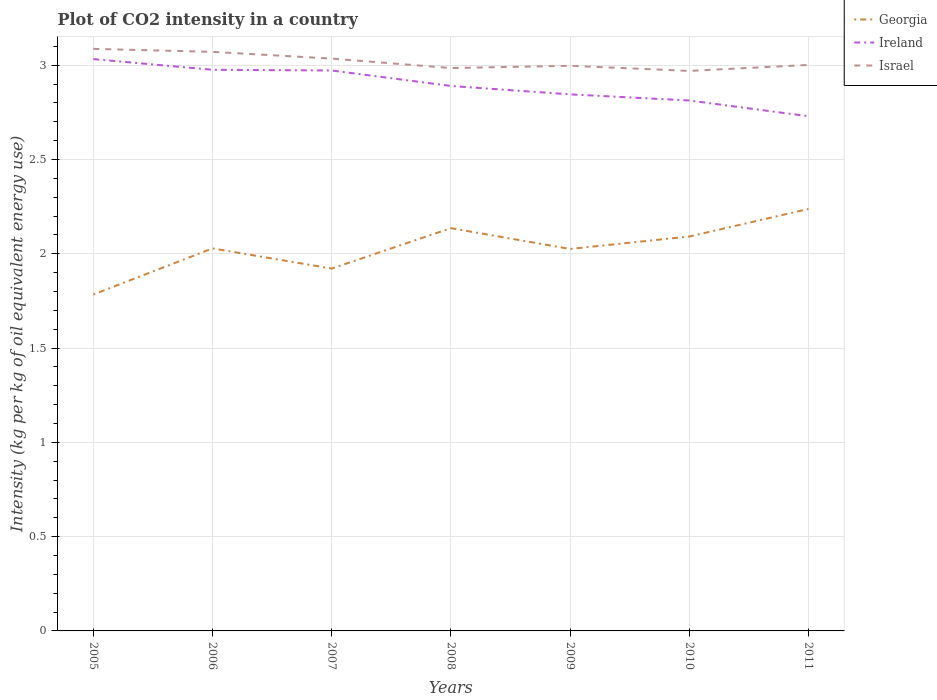How many different coloured lines are there?
Your response must be concise. 3. Does the line corresponding to Georgia intersect with the line corresponding to Ireland?
Your answer should be compact. No. Across all years, what is the maximum CO2 intensity in in Israel?
Keep it short and to the point. 2.97. What is the total CO2 intensity in in Ireland in the graph?
Your response must be concise. 0.24. What is the difference between the highest and the second highest CO2 intensity in in Israel?
Your answer should be compact. 0.12. What is the difference between the highest and the lowest CO2 intensity in in Georgia?
Your answer should be very brief. 3. How many lines are there?
Give a very brief answer. 3. What is the difference between two consecutive major ticks on the Y-axis?
Ensure brevity in your answer.  0.5. Does the graph contain any zero values?
Provide a succinct answer. No. Does the graph contain grids?
Your response must be concise. Yes. How many legend labels are there?
Keep it short and to the point. 3. What is the title of the graph?
Ensure brevity in your answer.  Plot of CO2 intensity in a country. What is the label or title of the Y-axis?
Ensure brevity in your answer.  Intensity (kg per kg of oil equivalent energy use). What is the Intensity (kg per kg of oil equivalent energy use) in Georgia in 2005?
Your answer should be compact. 1.78. What is the Intensity (kg per kg of oil equivalent energy use) in Ireland in 2005?
Your answer should be very brief. 3.03. What is the Intensity (kg per kg of oil equivalent energy use) of Israel in 2005?
Offer a very short reply. 3.09. What is the Intensity (kg per kg of oil equivalent energy use) of Georgia in 2006?
Your answer should be very brief. 2.03. What is the Intensity (kg per kg of oil equivalent energy use) in Ireland in 2006?
Your response must be concise. 2.98. What is the Intensity (kg per kg of oil equivalent energy use) of Israel in 2006?
Keep it short and to the point. 3.07. What is the Intensity (kg per kg of oil equivalent energy use) in Georgia in 2007?
Give a very brief answer. 1.92. What is the Intensity (kg per kg of oil equivalent energy use) in Ireland in 2007?
Give a very brief answer. 2.97. What is the Intensity (kg per kg of oil equivalent energy use) of Israel in 2007?
Your response must be concise. 3.04. What is the Intensity (kg per kg of oil equivalent energy use) of Georgia in 2008?
Your response must be concise. 2.14. What is the Intensity (kg per kg of oil equivalent energy use) of Ireland in 2008?
Offer a terse response. 2.89. What is the Intensity (kg per kg of oil equivalent energy use) in Israel in 2008?
Ensure brevity in your answer.  2.99. What is the Intensity (kg per kg of oil equivalent energy use) of Georgia in 2009?
Offer a terse response. 2.03. What is the Intensity (kg per kg of oil equivalent energy use) in Ireland in 2009?
Make the answer very short. 2.85. What is the Intensity (kg per kg of oil equivalent energy use) in Israel in 2009?
Ensure brevity in your answer.  3. What is the Intensity (kg per kg of oil equivalent energy use) of Georgia in 2010?
Make the answer very short. 2.09. What is the Intensity (kg per kg of oil equivalent energy use) in Ireland in 2010?
Provide a succinct answer. 2.81. What is the Intensity (kg per kg of oil equivalent energy use) of Israel in 2010?
Ensure brevity in your answer.  2.97. What is the Intensity (kg per kg of oil equivalent energy use) of Georgia in 2011?
Keep it short and to the point. 2.24. What is the Intensity (kg per kg of oil equivalent energy use) of Ireland in 2011?
Provide a succinct answer. 2.73. What is the Intensity (kg per kg of oil equivalent energy use) of Israel in 2011?
Give a very brief answer. 3. Across all years, what is the maximum Intensity (kg per kg of oil equivalent energy use) of Georgia?
Offer a terse response. 2.24. Across all years, what is the maximum Intensity (kg per kg of oil equivalent energy use) in Ireland?
Your answer should be very brief. 3.03. Across all years, what is the maximum Intensity (kg per kg of oil equivalent energy use) of Israel?
Your answer should be very brief. 3.09. Across all years, what is the minimum Intensity (kg per kg of oil equivalent energy use) in Georgia?
Provide a succinct answer. 1.78. Across all years, what is the minimum Intensity (kg per kg of oil equivalent energy use) in Ireland?
Give a very brief answer. 2.73. Across all years, what is the minimum Intensity (kg per kg of oil equivalent energy use) of Israel?
Provide a succinct answer. 2.97. What is the total Intensity (kg per kg of oil equivalent energy use) of Georgia in the graph?
Offer a terse response. 14.23. What is the total Intensity (kg per kg of oil equivalent energy use) in Ireland in the graph?
Provide a short and direct response. 20.26. What is the total Intensity (kg per kg of oil equivalent energy use) of Israel in the graph?
Give a very brief answer. 21.15. What is the difference between the Intensity (kg per kg of oil equivalent energy use) in Georgia in 2005 and that in 2006?
Ensure brevity in your answer.  -0.24. What is the difference between the Intensity (kg per kg of oil equivalent energy use) of Ireland in 2005 and that in 2006?
Your answer should be compact. 0.06. What is the difference between the Intensity (kg per kg of oil equivalent energy use) of Israel in 2005 and that in 2006?
Keep it short and to the point. 0.02. What is the difference between the Intensity (kg per kg of oil equivalent energy use) of Georgia in 2005 and that in 2007?
Offer a terse response. -0.14. What is the difference between the Intensity (kg per kg of oil equivalent energy use) of Ireland in 2005 and that in 2007?
Your response must be concise. 0.06. What is the difference between the Intensity (kg per kg of oil equivalent energy use) in Israel in 2005 and that in 2007?
Offer a terse response. 0.05. What is the difference between the Intensity (kg per kg of oil equivalent energy use) in Georgia in 2005 and that in 2008?
Keep it short and to the point. -0.35. What is the difference between the Intensity (kg per kg of oil equivalent energy use) in Ireland in 2005 and that in 2008?
Your answer should be compact. 0.14. What is the difference between the Intensity (kg per kg of oil equivalent energy use) of Israel in 2005 and that in 2008?
Provide a short and direct response. 0.1. What is the difference between the Intensity (kg per kg of oil equivalent energy use) in Georgia in 2005 and that in 2009?
Keep it short and to the point. -0.24. What is the difference between the Intensity (kg per kg of oil equivalent energy use) in Ireland in 2005 and that in 2009?
Your answer should be compact. 0.19. What is the difference between the Intensity (kg per kg of oil equivalent energy use) of Israel in 2005 and that in 2009?
Make the answer very short. 0.09. What is the difference between the Intensity (kg per kg of oil equivalent energy use) in Georgia in 2005 and that in 2010?
Give a very brief answer. -0.31. What is the difference between the Intensity (kg per kg of oil equivalent energy use) of Ireland in 2005 and that in 2010?
Your response must be concise. 0.22. What is the difference between the Intensity (kg per kg of oil equivalent energy use) of Israel in 2005 and that in 2010?
Your answer should be compact. 0.12. What is the difference between the Intensity (kg per kg of oil equivalent energy use) of Georgia in 2005 and that in 2011?
Provide a short and direct response. -0.45. What is the difference between the Intensity (kg per kg of oil equivalent energy use) of Ireland in 2005 and that in 2011?
Your answer should be very brief. 0.3. What is the difference between the Intensity (kg per kg of oil equivalent energy use) in Israel in 2005 and that in 2011?
Provide a succinct answer. 0.09. What is the difference between the Intensity (kg per kg of oil equivalent energy use) in Georgia in 2006 and that in 2007?
Ensure brevity in your answer.  0.11. What is the difference between the Intensity (kg per kg of oil equivalent energy use) in Ireland in 2006 and that in 2007?
Give a very brief answer. 0. What is the difference between the Intensity (kg per kg of oil equivalent energy use) of Israel in 2006 and that in 2007?
Provide a short and direct response. 0.04. What is the difference between the Intensity (kg per kg of oil equivalent energy use) of Georgia in 2006 and that in 2008?
Keep it short and to the point. -0.11. What is the difference between the Intensity (kg per kg of oil equivalent energy use) in Ireland in 2006 and that in 2008?
Offer a terse response. 0.09. What is the difference between the Intensity (kg per kg of oil equivalent energy use) of Israel in 2006 and that in 2008?
Offer a terse response. 0.09. What is the difference between the Intensity (kg per kg of oil equivalent energy use) in Georgia in 2006 and that in 2009?
Your response must be concise. 0. What is the difference between the Intensity (kg per kg of oil equivalent energy use) of Ireland in 2006 and that in 2009?
Ensure brevity in your answer.  0.13. What is the difference between the Intensity (kg per kg of oil equivalent energy use) of Israel in 2006 and that in 2009?
Provide a succinct answer. 0.07. What is the difference between the Intensity (kg per kg of oil equivalent energy use) in Georgia in 2006 and that in 2010?
Give a very brief answer. -0.06. What is the difference between the Intensity (kg per kg of oil equivalent energy use) of Ireland in 2006 and that in 2010?
Give a very brief answer. 0.16. What is the difference between the Intensity (kg per kg of oil equivalent energy use) in Israel in 2006 and that in 2010?
Give a very brief answer. 0.1. What is the difference between the Intensity (kg per kg of oil equivalent energy use) in Georgia in 2006 and that in 2011?
Give a very brief answer. -0.21. What is the difference between the Intensity (kg per kg of oil equivalent energy use) of Ireland in 2006 and that in 2011?
Offer a terse response. 0.25. What is the difference between the Intensity (kg per kg of oil equivalent energy use) in Israel in 2006 and that in 2011?
Keep it short and to the point. 0.07. What is the difference between the Intensity (kg per kg of oil equivalent energy use) in Georgia in 2007 and that in 2008?
Provide a succinct answer. -0.21. What is the difference between the Intensity (kg per kg of oil equivalent energy use) in Ireland in 2007 and that in 2008?
Offer a terse response. 0.08. What is the difference between the Intensity (kg per kg of oil equivalent energy use) in Israel in 2007 and that in 2008?
Give a very brief answer. 0.05. What is the difference between the Intensity (kg per kg of oil equivalent energy use) of Georgia in 2007 and that in 2009?
Your answer should be compact. -0.1. What is the difference between the Intensity (kg per kg of oil equivalent energy use) in Ireland in 2007 and that in 2009?
Provide a succinct answer. 0.13. What is the difference between the Intensity (kg per kg of oil equivalent energy use) of Israel in 2007 and that in 2009?
Give a very brief answer. 0.04. What is the difference between the Intensity (kg per kg of oil equivalent energy use) in Georgia in 2007 and that in 2010?
Your answer should be compact. -0.17. What is the difference between the Intensity (kg per kg of oil equivalent energy use) in Ireland in 2007 and that in 2010?
Give a very brief answer. 0.16. What is the difference between the Intensity (kg per kg of oil equivalent energy use) of Israel in 2007 and that in 2010?
Give a very brief answer. 0.07. What is the difference between the Intensity (kg per kg of oil equivalent energy use) in Georgia in 2007 and that in 2011?
Keep it short and to the point. -0.32. What is the difference between the Intensity (kg per kg of oil equivalent energy use) in Ireland in 2007 and that in 2011?
Make the answer very short. 0.24. What is the difference between the Intensity (kg per kg of oil equivalent energy use) in Israel in 2007 and that in 2011?
Make the answer very short. 0.03. What is the difference between the Intensity (kg per kg of oil equivalent energy use) in Georgia in 2008 and that in 2009?
Provide a succinct answer. 0.11. What is the difference between the Intensity (kg per kg of oil equivalent energy use) in Ireland in 2008 and that in 2009?
Your response must be concise. 0.04. What is the difference between the Intensity (kg per kg of oil equivalent energy use) of Israel in 2008 and that in 2009?
Ensure brevity in your answer.  -0.01. What is the difference between the Intensity (kg per kg of oil equivalent energy use) of Georgia in 2008 and that in 2010?
Offer a terse response. 0.04. What is the difference between the Intensity (kg per kg of oil equivalent energy use) of Ireland in 2008 and that in 2010?
Provide a short and direct response. 0.08. What is the difference between the Intensity (kg per kg of oil equivalent energy use) of Israel in 2008 and that in 2010?
Make the answer very short. 0.02. What is the difference between the Intensity (kg per kg of oil equivalent energy use) in Georgia in 2008 and that in 2011?
Provide a short and direct response. -0.1. What is the difference between the Intensity (kg per kg of oil equivalent energy use) in Ireland in 2008 and that in 2011?
Provide a short and direct response. 0.16. What is the difference between the Intensity (kg per kg of oil equivalent energy use) in Israel in 2008 and that in 2011?
Your answer should be very brief. -0.02. What is the difference between the Intensity (kg per kg of oil equivalent energy use) of Georgia in 2009 and that in 2010?
Your answer should be compact. -0.07. What is the difference between the Intensity (kg per kg of oil equivalent energy use) in Ireland in 2009 and that in 2010?
Give a very brief answer. 0.03. What is the difference between the Intensity (kg per kg of oil equivalent energy use) of Israel in 2009 and that in 2010?
Offer a terse response. 0.03. What is the difference between the Intensity (kg per kg of oil equivalent energy use) of Georgia in 2009 and that in 2011?
Make the answer very short. -0.21. What is the difference between the Intensity (kg per kg of oil equivalent energy use) of Ireland in 2009 and that in 2011?
Give a very brief answer. 0.12. What is the difference between the Intensity (kg per kg of oil equivalent energy use) of Israel in 2009 and that in 2011?
Your response must be concise. -0. What is the difference between the Intensity (kg per kg of oil equivalent energy use) of Georgia in 2010 and that in 2011?
Provide a short and direct response. -0.15. What is the difference between the Intensity (kg per kg of oil equivalent energy use) in Ireland in 2010 and that in 2011?
Offer a terse response. 0.08. What is the difference between the Intensity (kg per kg of oil equivalent energy use) in Israel in 2010 and that in 2011?
Offer a very short reply. -0.03. What is the difference between the Intensity (kg per kg of oil equivalent energy use) of Georgia in 2005 and the Intensity (kg per kg of oil equivalent energy use) of Ireland in 2006?
Offer a very short reply. -1.19. What is the difference between the Intensity (kg per kg of oil equivalent energy use) in Georgia in 2005 and the Intensity (kg per kg of oil equivalent energy use) in Israel in 2006?
Give a very brief answer. -1.29. What is the difference between the Intensity (kg per kg of oil equivalent energy use) in Ireland in 2005 and the Intensity (kg per kg of oil equivalent energy use) in Israel in 2006?
Give a very brief answer. -0.04. What is the difference between the Intensity (kg per kg of oil equivalent energy use) of Georgia in 2005 and the Intensity (kg per kg of oil equivalent energy use) of Ireland in 2007?
Ensure brevity in your answer.  -1.19. What is the difference between the Intensity (kg per kg of oil equivalent energy use) in Georgia in 2005 and the Intensity (kg per kg of oil equivalent energy use) in Israel in 2007?
Offer a very short reply. -1.25. What is the difference between the Intensity (kg per kg of oil equivalent energy use) of Ireland in 2005 and the Intensity (kg per kg of oil equivalent energy use) of Israel in 2007?
Your answer should be very brief. -0. What is the difference between the Intensity (kg per kg of oil equivalent energy use) of Georgia in 2005 and the Intensity (kg per kg of oil equivalent energy use) of Ireland in 2008?
Your answer should be very brief. -1.11. What is the difference between the Intensity (kg per kg of oil equivalent energy use) in Georgia in 2005 and the Intensity (kg per kg of oil equivalent energy use) in Israel in 2008?
Offer a very short reply. -1.2. What is the difference between the Intensity (kg per kg of oil equivalent energy use) of Ireland in 2005 and the Intensity (kg per kg of oil equivalent energy use) of Israel in 2008?
Your response must be concise. 0.05. What is the difference between the Intensity (kg per kg of oil equivalent energy use) of Georgia in 2005 and the Intensity (kg per kg of oil equivalent energy use) of Ireland in 2009?
Make the answer very short. -1.06. What is the difference between the Intensity (kg per kg of oil equivalent energy use) of Georgia in 2005 and the Intensity (kg per kg of oil equivalent energy use) of Israel in 2009?
Make the answer very short. -1.21. What is the difference between the Intensity (kg per kg of oil equivalent energy use) in Ireland in 2005 and the Intensity (kg per kg of oil equivalent energy use) in Israel in 2009?
Your response must be concise. 0.04. What is the difference between the Intensity (kg per kg of oil equivalent energy use) in Georgia in 2005 and the Intensity (kg per kg of oil equivalent energy use) in Ireland in 2010?
Offer a terse response. -1.03. What is the difference between the Intensity (kg per kg of oil equivalent energy use) in Georgia in 2005 and the Intensity (kg per kg of oil equivalent energy use) in Israel in 2010?
Your answer should be compact. -1.19. What is the difference between the Intensity (kg per kg of oil equivalent energy use) of Ireland in 2005 and the Intensity (kg per kg of oil equivalent energy use) of Israel in 2010?
Your answer should be very brief. 0.06. What is the difference between the Intensity (kg per kg of oil equivalent energy use) in Georgia in 2005 and the Intensity (kg per kg of oil equivalent energy use) in Ireland in 2011?
Provide a succinct answer. -0.95. What is the difference between the Intensity (kg per kg of oil equivalent energy use) in Georgia in 2005 and the Intensity (kg per kg of oil equivalent energy use) in Israel in 2011?
Provide a short and direct response. -1.22. What is the difference between the Intensity (kg per kg of oil equivalent energy use) of Ireland in 2005 and the Intensity (kg per kg of oil equivalent energy use) of Israel in 2011?
Ensure brevity in your answer.  0.03. What is the difference between the Intensity (kg per kg of oil equivalent energy use) of Georgia in 2006 and the Intensity (kg per kg of oil equivalent energy use) of Ireland in 2007?
Ensure brevity in your answer.  -0.94. What is the difference between the Intensity (kg per kg of oil equivalent energy use) of Georgia in 2006 and the Intensity (kg per kg of oil equivalent energy use) of Israel in 2007?
Give a very brief answer. -1.01. What is the difference between the Intensity (kg per kg of oil equivalent energy use) in Ireland in 2006 and the Intensity (kg per kg of oil equivalent energy use) in Israel in 2007?
Offer a very short reply. -0.06. What is the difference between the Intensity (kg per kg of oil equivalent energy use) in Georgia in 2006 and the Intensity (kg per kg of oil equivalent energy use) in Ireland in 2008?
Make the answer very short. -0.86. What is the difference between the Intensity (kg per kg of oil equivalent energy use) in Georgia in 2006 and the Intensity (kg per kg of oil equivalent energy use) in Israel in 2008?
Provide a short and direct response. -0.96. What is the difference between the Intensity (kg per kg of oil equivalent energy use) of Ireland in 2006 and the Intensity (kg per kg of oil equivalent energy use) of Israel in 2008?
Keep it short and to the point. -0.01. What is the difference between the Intensity (kg per kg of oil equivalent energy use) in Georgia in 2006 and the Intensity (kg per kg of oil equivalent energy use) in Ireland in 2009?
Your response must be concise. -0.82. What is the difference between the Intensity (kg per kg of oil equivalent energy use) in Georgia in 2006 and the Intensity (kg per kg of oil equivalent energy use) in Israel in 2009?
Your answer should be compact. -0.97. What is the difference between the Intensity (kg per kg of oil equivalent energy use) of Ireland in 2006 and the Intensity (kg per kg of oil equivalent energy use) of Israel in 2009?
Provide a short and direct response. -0.02. What is the difference between the Intensity (kg per kg of oil equivalent energy use) in Georgia in 2006 and the Intensity (kg per kg of oil equivalent energy use) in Ireland in 2010?
Your response must be concise. -0.78. What is the difference between the Intensity (kg per kg of oil equivalent energy use) in Georgia in 2006 and the Intensity (kg per kg of oil equivalent energy use) in Israel in 2010?
Your answer should be compact. -0.94. What is the difference between the Intensity (kg per kg of oil equivalent energy use) of Ireland in 2006 and the Intensity (kg per kg of oil equivalent energy use) of Israel in 2010?
Provide a succinct answer. 0.01. What is the difference between the Intensity (kg per kg of oil equivalent energy use) in Georgia in 2006 and the Intensity (kg per kg of oil equivalent energy use) in Ireland in 2011?
Ensure brevity in your answer.  -0.7. What is the difference between the Intensity (kg per kg of oil equivalent energy use) of Georgia in 2006 and the Intensity (kg per kg of oil equivalent energy use) of Israel in 2011?
Your answer should be compact. -0.97. What is the difference between the Intensity (kg per kg of oil equivalent energy use) in Ireland in 2006 and the Intensity (kg per kg of oil equivalent energy use) in Israel in 2011?
Your response must be concise. -0.03. What is the difference between the Intensity (kg per kg of oil equivalent energy use) of Georgia in 2007 and the Intensity (kg per kg of oil equivalent energy use) of Ireland in 2008?
Your answer should be very brief. -0.97. What is the difference between the Intensity (kg per kg of oil equivalent energy use) in Georgia in 2007 and the Intensity (kg per kg of oil equivalent energy use) in Israel in 2008?
Provide a succinct answer. -1.06. What is the difference between the Intensity (kg per kg of oil equivalent energy use) in Ireland in 2007 and the Intensity (kg per kg of oil equivalent energy use) in Israel in 2008?
Ensure brevity in your answer.  -0.01. What is the difference between the Intensity (kg per kg of oil equivalent energy use) in Georgia in 2007 and the Intensity (kg per kg of oil equivalent energy use) in Ireland in 2009?
Ensure brevity in your answer.  -0.92. What is the difference between the Intensity (kg per kg of oil equivalent energy use) in Georgia in 2007 and the Intensity (kg per kg of oil equivalent energy use) in Israel in 2009?
Provide a succinct answer. -1.08. What is the difference between the Intensity (kg per kg of oil equivalent energy use) in Ireland in 2007 and the Intensity (kg per kg of oil equivalent energy use) in Israel in 2009?
Offer a terse response. -0.02. What is the difference between the Intensity (kg per kg of oil equivalent energy use) of Georgia in 2007 and the Intensity (kg per kg of oil equivalent energy use) of Ireland in 2010?
Provide a succinct answer. -0.89. What is the difference between the Intensity (kg per kg of oil equivalent energy use) of Georgia in 2007 and the Intensity (kg per kg of oil equivalent energy use) of Israel in 2010?
Provide a short and direct response. -1.05. What is the difference between the Intensity (kg per kg of oil equivalent energy use) in Ireland in 2007 and the Intensity (kg per kg of oil equivalent energy use) in Israel in 2010?
Offer a very short reply. 0. What is the difference between the Intensity (kg per kg of oil equivalent energy use) in Georgia in 2007 and the Intensity (kg per kg of oil equivalent energy use) in Ireland in 2011?
Your answer should be compact. -0.81. What is the difference between the Intensity (kg per kg of oil equivalent energy use) of Georgia in 2007 and the Intensity (kg per kg of oil equivalent energy use) of Israel in 2011?
Give a very brief answer. -1.08. What is the difference between the Intensity (kg per kg of oil equivalent energy use) in Ireland in 2007 and the Intensity (kg per kg of oil equivalent energy use) in Israel in 2011?
Offer a terse response. -0.03. What is the difference between the Intensity (kg per kg of oil equivalent energy use) in Georgia in 2008 and the Intensity (kg per kg of oil equivalent energy use) in Ireland in 2009?
Provide a short and direct response. -0.71. What is the difference between the Intensity (kg per kg of oil equivalent energy use) in Georgia in 2008 and the Intensity (kg per kg of oil equivalent energy use) in Israel in 2009?
Give a very brief answer. -0.86. What is the difference between the Intensity (kg per kg of oil equivalent energy use) in Ireland in 2008 and the Intensity (kg per kg of oil equivalent energy use) in Israel in 2009?
Ensure brevity in your answer.  -0.11. What is the difference between the Intensity (kg per kg of oil equivalent energy use) in Georgia in 2008 and the Intensity (kg per kg of oil equivalent energy use) in Ireland in 2010?
Your answer should be compact. -0.68. What is the difference between the Intensity (kg per kg of oil equivalent energy use) of Georgia in 2008 and the Intensity (kg per kg of oil equivalent energy use) of Israel in 2010?
Offer a very short reply. -0.83. What is the difference between the Intensity (kg per kg of oil equivalent energy use) of Ireland in 2008 and the Intensity (kg per kg of oil equivalent energy use) of Israel in 2010?
Your answer should be compact. -0.08. What is the difference between the Intensity (kg per kg of oil equivalent energy use) in Georgia in 2008 and the Intensity (kg per kg of oil equivalent energy use) in Ireland in 2011?
Your response must be concise. -0.59. What is the difference between the Intensity (kg per kg of oil equivalent energy use) of Georgia in 2008 and the Intensity (kg per kg of oil equivalent energy use) of Israel in 2011?
Give a very brief answer. -0.87. What is the difference between the Intensity (kg per kg of oil equivalent energy use) in Ireland in 2008 and the Intensity (kg per kg of oil equivalent energy use) in Israel in 2011?
Your answer should be very brief. -0.11. What is the difference between the Intensity (kg per kg of oil equivalent energy use) in Georgia in 2009 and the Intensity (kg per kg of oil equivalent energy use) in Ireland in 2010?
Provide a succinct answer. -0.79. What is the difference between the Intensity (kg per kg of oil equivalent energy use) of Georgia in 2009 and the Intensity (kg per kg of oil equivalent energy use) of Israel in 2010?
Provide a succinct answer. -0.94. What is the difference between the Intensity (kg per kg of oil equivalent energy use) of Ireland in 2009 and the Intensity (kg per kg of oil equivalent energy use) of Israel in 2010?
Your response must be concise. -0.12. What is the difference between the Intensity (kg per kg of oil equivalent energy use) of Georgia in 2009 and the Intensity (kg per kg of oil equivalent energy use) of Ireland in 2011?
Make the answer very short. -0.7. What is the difference between the Intensity (kg per kg of oil equivalent energy use) of Georgia in 2009 and the Intensity (kg per kg of oil equivalent energy use) of Israel in 2011?
Offer a very short reply. -0.98. What is the difference between the Intensity (kg per kg of oil equivalent energy use) in Ireland in 2009 and the Intensity (kg per kg of oil equivalent energy use) in Israel in 2011?
Make the answer very short. -0.16. What is the difference between the Intensity (kg per kg of oil equivalent energy use) of Georgia in 2010 and the Intensity (kg per kg of oil equivalent energy use) of Ireland in 2011?
Your answer should be very brief. -0.64. What is the difference between the Intensity (kg per kg of oil equivalent energy use) in Georgia in 2010 and the Intensity (kg per kg of oil equivalent energy use) in Israel in 2011?
Give a very brief answer. -0.91. What is the difference between the Intensity (kg per kg of oil equivalent energy use) of Ireland in 2010 and the Intensity (kg per kg of oil equivalent energy use) of Israel in 2011?
Give a very brief answer. -0.19. What is the average Intensity (kg per kg of oil equivalent energy use) of Georgia per year?
Offer a terse response. 2.03. What is the average Intensity (kg per kg of oil equivalent energy use) in Ireland per year?
Keep it short and to the point. 2.89. What is the average Intensity (kg per kg of oil equivalent energy use) of Israel per year?
Your response must be concise. 3.02. In the year 2005, what is the difference between the Intensity (kg per kg of oil equivalent energy use) of Georgia and Intensity (kg per kg of oil equivalent energy use) of Ireland?
Offer a very short reply. -1.25. In the year 2005, what is the difference between the Intensity (kg per kg of oil equivalent energy use) in Georgia and Intensity (kg per kg of oil equivalent energy use) in Israel?
Your answer should be compact. -1.3. In the year 2005, what is the difference between the Intensity (kg per kg of oil equivalent energy use) of Ireland and Intensity (kg per kg of oil equivalent energy use) of Israel?
Keep it short and to the point. -0.05. In the year 2006, what is the difference between the Intensity (kg per kg of oil equivalent energy use) of Georgia and Intensity (kg per kg of oil equivalent energy use) of Ireland?
Offer a terse response. -0.95. In the year 2006, what is the difference between the Intensity (kg per kg of oil equivalent energy use) of Georgia and Intensity (kg per kg of oil equivalent energy use) of Israel?
Provide a succinct answer. -1.04. In the year 2006, what is the difference between the Intensity (kg per kg of oil equivalent energy use) in Ireland and Intensity (kg per kg of oil equivalent energy use) in Israel?
Give a very brief answer. -0.1. In the year 2007, what is the difference between the Intensity (kg per kg of oil equivalent energy use) of Georgia and Intensity (kg per kg of oil equivalent energy use) of Ireland?
Your response must be concise. -1.05. In the year 2007, what is the difference between the Intensity (kg per kg of oil equivalent energy use) of Georgia and Intensity (kg per kg of oil equivalent energy use) of Israel?
Ensure brevity in your answer.  -1.11. In the year 2007, what is the difference between the Intensity (kg per kg of oil equivalent energy use) of Ireland and Intensity (kg per kg of oil equivalent energy use) of Israel?
Offer a very short reply. -0.06. In the year 2008, what is the difference between the Intensity (kg per kg of oil equivalent energy use) of Georgia and Intensity (kg per kg of oil equivalent energy use) of Ireland?
Provide a short and direct response. -0.75. In the year 2008, what is the difference between the Intensity (kg per kg of oil equivalent energy use) in Georgia and Intensity (kg per kg of oil equivalent energy use) in Israel?
Make the answer very short. -0.85. In the year 2008, what is the difference between the Intensity (kg per kg of oil equivalent energy use) in Ireland and Intensity (kg per kg of oil equivalent energy use) in Israel?
Offer a terse response. -0.1. In the year 2009, what is the difference between the Intensity (kg per kg of oil equivalent energy use) of Georgia and Intensity (kg per kg of oil equivalent energy use) of Ireland?
Give a very brief answer. -0.82. In the year 2009, what is the difference between the Intensity (kg per kg of oil equivalent energy use) of Georgia and Intensity (kg per kg of oil equivalent energy use) of Israel?
Your answer should be very brief. -0.97. In the year 2009, what is the difference between the Intensity (kg per kg of oil equivalent energy use) of Ireland and Intensity (kg per kg of oil equivalent energy use) of Israel?
Keep it short and to the point. -0.15. In the year 2010, what is the difference between the Intensity (kg per kg of oil equivalent energy use) in Georgia and Intensity (kg per kg of oil equivalent energy use) in Ireland?
Your answer should be very brief. -0.72. In the year 2010, what is the difference between the Intensity (kg per kg of oil equivalent energy use) in Georgia and Intensity (kg per kg of oil equivalent energy use) in Israel?
Your answer should be very brief. -0.88. In the year 2010, what is the difference between the Intensity (kg per kg of oil equivalent energy use) of Ireland and Intensity (kg per kg of oil equivalent energy use) of Israel?
Offer a terse response. -0.16. In the year 2011, what is the difference between the Intensity (kg per kg of oil equivalent energy use) of Georgia and Intensity (kg per kg of oil equivalent energy use) of Ireland?
Ensure brevity in your answer.  -0.49. In the year 2011, what is the difference between the Intensity (kg per kg of oil equivalent energy use) in Georgia and Intensity (kg per kg of oil equivalent energy use) in Israel?
Provide a short and direct response. -0.76. In the year 2011, what is the difference between the Intensity (kg per kg of oil equivalent energy use) in Ireland and Intensity (kg per kg of oil equivalent energy use) in Israel?
Keep it short and to the point. -0.27. What is the ratio of the Intensity (kg per kg of oil equivalent energy use) of Georgia in 2005 to that in 2006?
Your answer should be very brief. 0.88. What is the ratio of the Intensity (kg per kg of oil equivalent energy use) in Israel in 2005 to that in 2006?
Your answer should be compact. 1.01. What is the ratio of the Intensity (kg per kg of oil equivalent energy use) in Georgia in 2005 to that in 2007?
Give a very brief answer. 0.93. What is the ratio of the Intensity (kg per kg of oil equivalent energy use) of Ireland in 2005 to that in 2007?
Ensure brevity in your answer.  1.02. What is the ratio of the Intensity (kg per kg of oil equivalent energy use) of Israel in 2005 to that in 2007?
Offer a terse response. 1.02. What is the ratio of the Intensity (kg per kg of oil equivalent energy use) of Georgia in 2005 to that in 2008?
Provide a succinct answer. 0.84. What is the ratio of the Intensity (kg per kg of oil equivalent energy use) in Ireland in 2005 to that in 2008?
Provide a succinct answer. 1.05. What is the ratio of the Intensity (kg per kg of oil equivalent energy use) in Israel in 2005 to that in 2008?
Ensure brevity in your answer.  1.03. What is the ratio of the Intensity (kg per kg of oil equivalent energy use) of Georgia in 2005 to that in 2009?
Keep it short and to the point. 0.88. What is the ratio of the Intensity (kg per kg of oil equivalent energy use) in Ireland in 2005 to that in 2009?
Ensure brevity in your answer.  1.07. What is the ratio of the Intensity (kg per kg of oil equivalent energy use) in Israel in 2005 to that in 2009?
Give a very brief answer. 1.03. What is the ratio of the Intensity (kg per kg of oil equivalent energy use) in Georgia in 2005 to that in 2010?
Provide a succinct answer. 0.85. What is the ratio of the Intensity (kg per kg of oil equivalent energy use) of Ireland in 2005 to that in 2010?
Provide a succinct answer. 1.08. What is the ratio of the Intensity (kg per kg of oil equivalent energy use) of Israel in 2005 to that in 2010?
Your answer should be very brief. 1.04. What is the ratio of the Intensity (kg per kg of oil equivalent energy use) of Georgia in 2005 to that in 2011?
Your answer should be very brief. 0.8. What is the ratio of the Intensity (kg per kg of oil equivalent energy use) in Ireland in 2005 to that in 2011?
Provide a short and direct response. 1.11. What is the ratio of the Intensity (kg per kg of oil equivalent energy use) in Israel in 2005 to that in 2011?
Offer a very short reply. 1.03. What is the ratio of the Intensity (kg per kg of oil equivalent energy use) in Georgia in 2006 to that in 2007?
Provide a short and direct response. 1.06. What is the ratio of the Intensity (kg per kg of oil equivalent energy use) in Ireland in 2006 to that in 2007?
Provide a succinct answer. 1. What is the ratio of the Intensity (kg per kg of oil equivalent energy use) in Israel in 2006 to that in 2007?
Ensure brevity in your answer.  1.01. What is the ratio of the Intensity (kg per kg of oil equivalent energy use) of Georgia in 2006 to that in 2008?
Give a very brief answer. 0.95. What is the ratio of the Intensity (kg per kg of oil equivalent energy use) in Ireland in 2006 to that in 2008?
Keep it short and to the point. 1.03. What is the ratio of the Intensity (kg per kg of oil equivalent energy use) in Israel in 2006 to that in 2008?
Your response must be concise. 1.03. What is the ratio of the Intensity (kg per kg of oil equivalent energy use) in Ireland in 2006 to that in 2009?
Make the answer very short. 1.05. What is the ratio of the Intensity (kg per kg of oil equivalent energy use) in Israel in 2006 to that in 2009?
Your response must be concise. 1.02. What is the ratio of the Intensity (kg per kg of oil equivalent energy use) in Georgia in 2006 to that in 2010?
Give a very brief answer. 0.97. What is the ratio of the Intensity (kg per kg of oil equivalent energy use) of Ireland in 2006 to that in 2010?
Your answer should be very brief. 1.06. What is the ratio of the Intensity (kg per kg of oil equivalent energy use) of Israel in 2006 to that in 2010?
Ensure brevity in your answer.  1.03. What is the ratio of the Intensity (kg per kg of oil equivalent energy use) of Georgia in 2006 to that in 2011?
Provide a succinct answer. 0.91. What is the ratio of the Intensity (kg per kg of oil equivalent energy use) in Ireland in 2006 to that in 2011?
Ensure brevity in your answer.  1.09. What is the ratio of the Intensity (kg per kg of oil equivalent energy use) of Israel in 2006 to that in 2011?
Your response must be concise. 1.02. What is the ratio of the Intensity (kg per kg of oil equivalent energy use) in Georgia in 2007 to that in 2008?
Your answer should be compact. 0.9. What is the ratio of the Intensity (kg per kg of oil equivalent energy use) in Ireland in 2007 to that in 2008?
Your answer should be compact. 1.03. What is the ratio of the Intensity (kg per kg of oil equivalent energy use) of Israel in 2007 to that in 2008?
Provide a succinct answer. 1.02. What is the ratio of the Intensity (kg per kg of oil equivalent energy use) of Georgia in 2007 to that in 2009?
Provide a short and direct response. 0.95. What is the ratio of the Intensity (kg per kg of oil equivalent energy use) in Ireland in 2007 to that in 2009?
Provide a short and direct response. 1.04. What is the ratio of the Intensity (kg per kg of oil equivalent energy use) in Israel in 2007 to that in 2009?
Provide a succinct answer. 1.01. What is the ratio of the Intensity (kg per kg of oil equivalent energy use) of Georgia in 2007 to that in 2010?
Offer a very short reply. 0.92. What is the ratio of the Intensity (kg per kg of oil equivalent energy use) in Ireland in 2007 to that in 2010?
Provide a succinct answer. 1.06. What is the ratio of the Intensity (kg per kg of oil equivalent energy use) of Israel in 2007 to that in 2010?
Offer a terse response. 1.02. What is the ratio of the Intensity (kg per kg of oil equivalent energy use) of Georgia in 2007 to that in 2011?
Offer a very short reply. 0.86. What is the ratio of the Intensity (kg per kg of oil equivalent energy use) of Ireland in 2007 to that in 2011?
Offer a terse response. 1.09. What is the ratio of the Intensity (kg per kg of oil equivalent energy use) of Israel in 2007 to that in 2011?
Keep it short and to the point. 1.01. What is the ratio of the Intensity (kg per kg of oil equivalent energy use) of Georgia in 2008 to that in 2009?
Offer a very short reply. 1.05. What is the ratio of the Intensity (kg per kg of oil equivalent energy use) of Ireland in 2008 to that in 2009?
Provide a succinct answer. 1.02. What is the ratio of the Intensity (kg per kg of oil equivalent energy use) of Israel in 2008 to that in 2009?
Provide a succinct answer. 1. What is the ratio of the Intensity (kg per kg of oil equivalent energy use) in Georgia in 2008 to that in 2010?
Your answer should be very brief. 1.02. What is the ratio of the Intensity (kg per kg of oil equivalent energy use) of Ireland in 2008 to that in 2010?
Provide a short and direct response. 1.03. What is the ratio of the Intensity (kg per kg of oil equivalent energy use) of Georgia in 2008 to that in 2011?
Your response must be concise. 0.95. What is the ratio of the Intensity (kg per kg of oil equivalent energy use) of Ireland in 2008 to that in 2011?
Give a very brief answer. 1.06. What is the ratio of the Intensity (kg per kg of oil equivalent energy use) in Israel in 2008 to that in 2011?
Your answer should be very brief. 0.99. What is the ratio of the Intensity (kg per kg of oil equivalent energy use) of Georgia in 2009 to that in 2010?
Offer a very short reply. 0.97. What is the ratio of the Intensity (kg per kg of oil equivalent energy use) in Ireland in 2009 to that in 2010?
Ensure brevity in your answer.  1.01. What is the ratio of the Intensity (kg per kg of oil equivalent energy use) in Israel in 2009 to that in 2010?
Keep it short and to the point. 1.01. What is the ratio of the Intensity (kg per kg of oil equivalent energy use) of Georgia in 2009 to that in 2011?
Provide a short and direct response. 0.91. What is the ratio of the Intensity (kg per kg of oil equivalent energy use) in Ireland in 2009 to that in 2011?
Provide a short and direct response. 1.04. What is the ratio of the Intensity (kg per kg of oil equivalent energy use) in Israel in 2009 to that in 2011?
Provide a succinct answer. 1. What is the ratio of the Intensity (kg per kg of oil equivalent energy use) in Georgia in 2010 to that in 2011?
Keep it short and to the point. 0.93. What is the ratio of the Intensity (kg per kg of oil equivalent energy use) in Ireland in 2010 to that in 2011?
Your answer should be very brief. 1.03. What is the difference between the highest and the second highest Intensity (kg per kg of oil equivalent energy use) in Georgia?
Your answer should be compact. 0.1. What is the difference between the highest and the second highest Intensity (kg per kg of oil equivalent energy use) in Ireland?
Make the answer very short. 0.06. What is the difference between the highest and the second highest Intensity (kg per kg of oil equivalent energy use) of Israel?
Your answer should be compact. 0.02. What is the difference between the highest and the lowest Intensity (kg per kg of oil equivalent energy use) of Georgia?
Give a very brief answer. 0.45. What is the difference between the highest and the lowest Intensity (kg per kg of oil equivalent energy use) of Ireland?
Your answer should be compact. 0.3. What is the difference between the highest and the lowest Intensity (kg per kg of oil equivalent energy use) of Israel?
Provide a short and direct response. 0.12. 